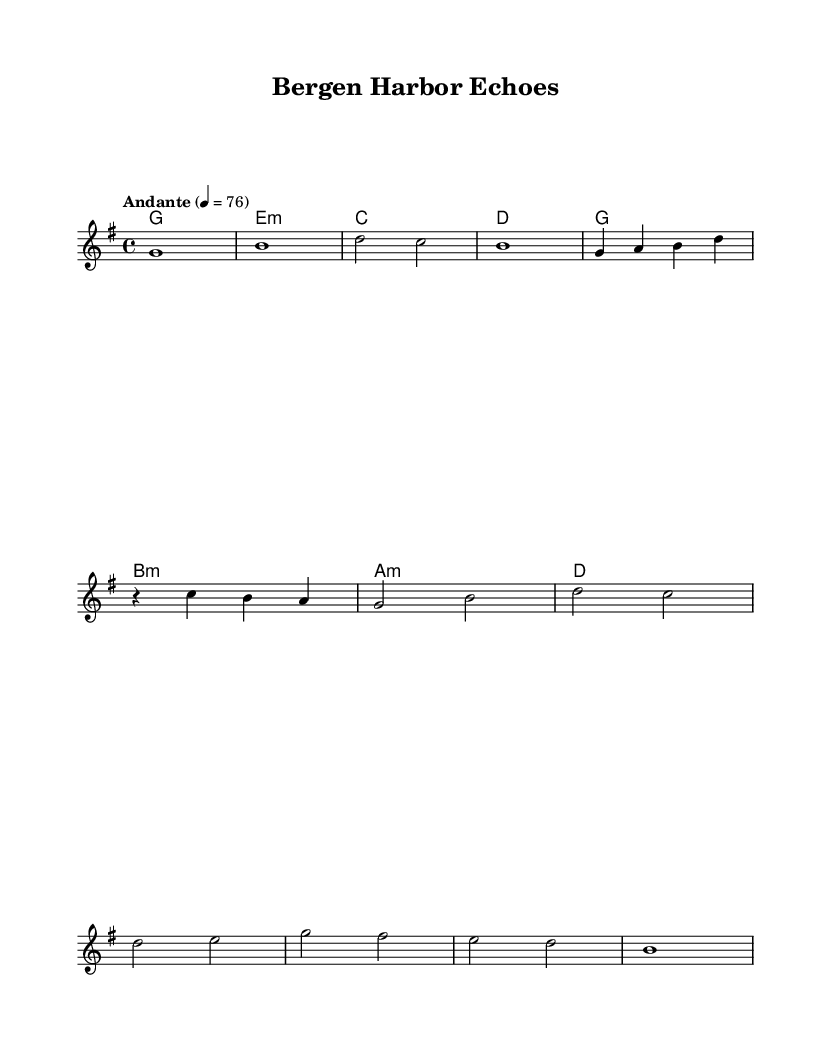What is the key signature of this music? The key signature is G major, which has one sharp (F#). This can be observed at the beginning of the staff where the sharp symbol is placed.
Answer: G major What is the time signature of this music? The time signature is 4/4, which is indicated at the beginning of the sheet music as two stacked numbers. The "4" on the top indicates four beats per measure, and the "4" on the bottom indicates that the quarter note gets one beat.
Answer: 4/4 What is the tempo marking for this piece? The tempo marking is "Andante" at quarter note equals 76, which is specified at the beginning of the score. This indicates a moderate walking pace.
Answer: Andante What is the first note of the melody? The first note of the melody is G, as seen at the start of the melody line in the staff.
Answer: G How many measures are in the chorus section? The chorus section consists of four measures, which is determined by counting the bar lines that separate each measure in the score.
Answer: Four What is the harmonic structure used in the verse section? The harmonic structure in the verse consists of the chords G, A minor, B minor, D, and returns to G, as they are indicated in the chord section above the melody. Each chord corresponds to the respective measures in the melody.
Answer: G, A minor, B minor, D What is the overall mood suggested by the title "Bergen Harbor Echoes"? The overall mood suggested by the title implies a serene and reflective atmosphere, resonating with the maritime setting of Bergen's harbor, enhanced by ambient electronic music characteristics.
Answer: Serene 